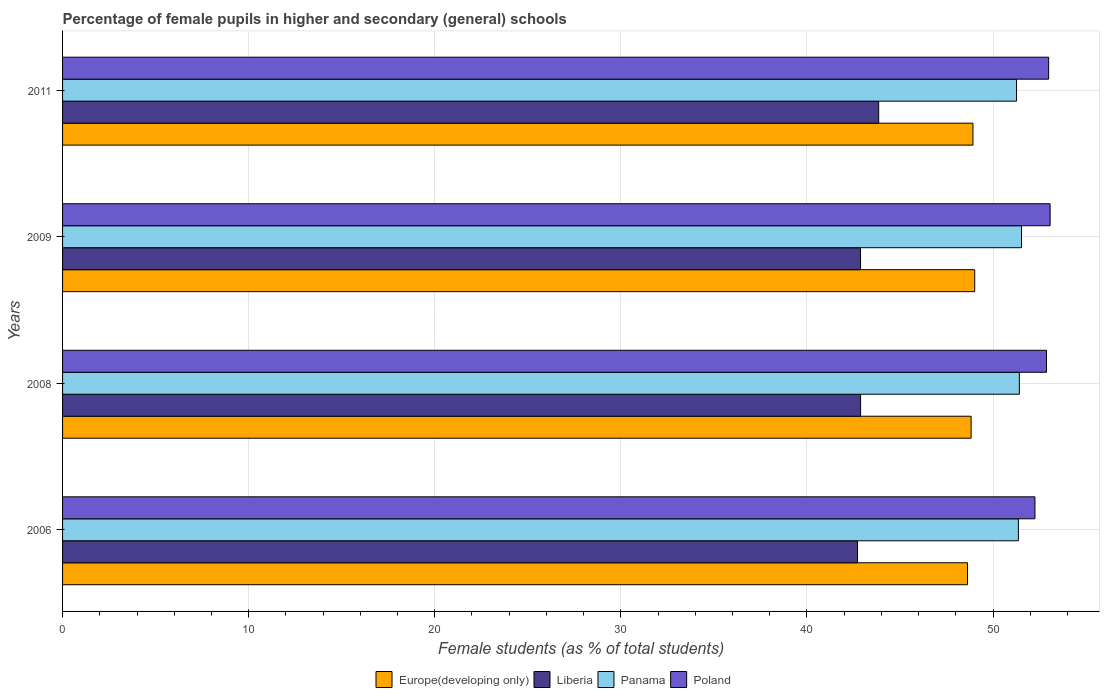How many different coloured bars are there?
Your answer should be compact. 4. How many bars are there on the 3rd tick from the bottom?
Give a very brief answer. 4. In how many cases, is the number of bars for a given year not equal to the number of legend labels?
Your answer should be compact. 0. What is the percentage of female pupils in higher and secondary schools in Panama in 2008?
Make the answer very short. 51.41. Across all years, what is the maximum percentage of female pupils in higher and secondary schools in Poland?
Provide a short and direct response. 53.07. Across all years, what is the minimum percentage of female pupils in higher and secondary schools in Poland?
Make the answer very short. 52.25. In which year was the percentage of female pupils in higher and secondary schools in Poland maximum?
Ensure brevity in your answer.  2009. In which year was the percentage of female pupils in higher and secondary schools in Poland minimum?
Ensure brevity in your answer.  2006. What is the total percentage of female pupils in higher and secondary schools in Liberia in the graph?
Ensure brevity in your answer.  172.34. What is the difference between the percentage of female pupils in higher and secondary schools in Panama in 2008 and that in 2009?
Your answer should be compact. -0.12. What is the difference between the percentage of female pupils in higher and secondary schools in Poland in 2006 and the percentage of female pupils in higher and secondary schools in Europe(developing only) in 2011?
Provide a succinct answer. 3.33. What is the average percentage of female pupils in higher and secondary schools in Liberia per year?
Your answer should be very brief. 43.08. In the year 2011, what is the difference between the percentage of female pupils in higher and secondary schools in Europe(developing only) and percentage of female pupils in higher and secondary schools in Liberia?
Provide a short and direct response. 5.07. In how many years, is the percentage of female pupils in higher and secondary schools in Poland greater than 42 %?
Offer a very short reply. 4. What is the ratio of the percentage of female pupils in higher and secondary schools in Europe(developing only) in 2009 to that in 2011?
Give a very brief answer. 1. Is the percentage of female pupils in higher and secondary schools in Poland in 2008 less than that in 2011?
Give a very brief answer. Yes. Is the difference between the percentage of female pupils in higher and secondary schools in Europe(developing only) in 2006 and 2009 greater than the difference between the percentage of female pupils in higher and secondary schools in Liberia in 2006 and 2009?
Your answer should be very brief. No. What is the difference between the highest and the second highest percentage of female pupils in higher and secondary schools in Europe(developing only)?
Offer a very short reply. 0.09. What is the difference between the highest and the lowest percentage of female pupils in higher and secondary schools in Liberia?
Your answer should be very brief. 1.14. Is it the case that in every year, the sum of the percentage of female pupils in higher and secondary schools in Liberia and percentage of female pupils in higher and secondary schools in Poland is greater than the sum of percentage of female pupils in higher and secondary schools in Europe(developing only) and percentage of female pupils in higher and secondary schools in Panama?
Provide a short and direct response. Yes. What does the 3rd bar from the top in 2008 represents?
Provide a short and direct response. Liberia. What does the 3rd bar from the bottom in 2011 represents?
Provide a succinct answer. Panama. How many bars are there?
Your answer should be compact. 16. How many years are there in the graph?
Your answer should be compact. 4. What is the difference between two consecutive major ticks on the X-axis?
Keep it short and to the point. 10. Does the graph contain grids?
Your answer should be very brief. Yes. Where does the legend appear in the graph?
Provide a short and direct response. Bottom center. How many legend labels are there?
Make the answer very short. 4. How are the legend labels stacked?
Provide a succinct answer. Horizontal. What is the title of the graph?
Your answer should be very brief. Percentage of female pupils in higher and secondary (general) schools. Does "Madagascar" appear as one of the legend labels in the graph?
Provide a succinct answer. No. What is the label or title of the X-axis?
Offer a terse response. Female students (as % of total students). What is the label or title of the Y-axis?
Give a very brief answer. Years. What is the Female students (as % of total students) in Europe(developing only) in 2006?
Provide a short and direct response. 48.63. What is the Female students (as % of total students) in Liberia in 2006?
Keep it short and to the point. 42.72. What is the Female students (as % of total students) of Panama in 2006?
Your answer should be compact. 51.36. What is the Female students (as % of total students) of Poland in 2006?
Give a very brief answer. 52.25. What is the Female students (as % of total students) of Europe(developing only) in 2008?
Keep it short and to the point. 48.82. What is the Female students (as % of total students) in Liberia in 2008?
Keep it short and to the point. 42.88. What is the Female students (as % of total students) of Panama in 2008?
Make the answer very short. 51.41. What is the Female students (as % of total students) of Poland in 2008?
Provide a short and direct response. 52.87. What is the Female students (as % of total students) of Europe(developing only) in 2009?
Your response must be concise. 49.02. What is the Female students (as % of total students) in Liberia in 2009?
Offer a terse response. 42.88. What is the Female students (as % of total students) in Panama in 2009?
Offer a terse response. 51.53. What is the Female students (as % of total students) of Poland in 2009?
Your response must be concise. 53.07. What is the Female students (as % of total students) in Europe(developing only) in 2011?
Give a very brief answer. 48.92. What is the Female students (as % of total students) in Liberia in 2011?
Offer a terse response. 43.85. What is the Female students (as % of total students) in Panama in 2011?
Keep it short and to the point. 51.26. What is the Female students (as % of total students) in Poland in 2011?
Provide a succinct answer. 52.99. Across all years, what is the maximum Female students (as % of total students) of Europe(developing only)?
Offer a very short reply. 49.02. Across all years, what is the maximum Female students (as % of total students) of Liberia?
Offer a terse response. 43.85. Across all years, what is the maximum Female students (as % of total students) in Panama?
Your answer should be very brief. 51.53. Across all years, what is the maximum Female students (as % of total students) in Poland?
Offer a very short reply. 53.07. Across all years, what is the minimum Female students (as % of total students) of Europe(developing only)?
Your answer should be very brief. 48.63. Across all years, what is the minimum Female students (as % of total students) of Liberia?
Provide a succinct answer. 42.72. Across all years, what is the minimum Female students (as % of total students) in Panama?
Provide a short and direct response. 51.26. Across all years, what is the minimum Female students (as % of total students) of Poland?
Your answer should be very brief. 52.25. What is the total Female students (as % of total students) in Europe(developing only) in the graph?
Offer a terse response. 195.38. What is the total Female students (as % of total students) of Liberia in the graph?
Your answer should be very brief. 172.34. What is the total Female students (as % of total students) in Panama in the graph?
Ensure brevity in your answer.  205.57. What is the total Female students (as % of total students) in Poland in the graph?
Your answer should be compact. 211.18. What is the difference between the Female students (as % of total students) in Europe(developing only) in 2006 and that in 2008?
Keep it short and to the point. -0.2. What is the difference between the Female students (as % of total students) in Liberia in 2006 and that in 2008?
Keep it short and to the point. -0.17. What is the difference between the Female students (as % of total students) in Panama in 2006 and that in 2008?
Give a very brief answer. -0.05. What is the difference between the Female students (as % of total students) of Poland in 2006 and that in 2008?
Provide a short and direct response. -0.62. What is the difference between the Female students (as % of total students) of Europe(developing only) in 2006 and that in 2009?
Offer a very short reply. -0.39. What is the difference between the Female students (as % of total students) in Liberia in 2006 and that in 2009?
Ensure brevity in your answer.  -0.16. What is the difference between the Female students (as % of total students) of Panama in 2006 and that in 2009?
Provide a short and direct response. -0.17. What is the difference between the Female students (as % of total students) in Poland in 2006 and that in 2009?
Provide a succinct answer. -0.81. What is the difference between the Female students (as % of total students) in Europe(developing only) in 2006 and that in 2011?
Provide a short and direct response. -0.29. What is the difference between the Female students (as % of total students) in Liberia in 2006 and that in 2011?
Your answer should be compact. -1.14. What is the difference between the Female students (as % of total students) in Panama in 2006 and that in 2011?
Provide a succinct answer. 0.1. What is the difference between the Female students (as % of total students) in Poland in 2006 and that in 2011?
Give a very brief answer. -0.74. What is the difference between the Female students (as % of total students) in Europe(developing only) in 2008 and that in 2009?
Ensure brevity in your answer.  -0.19. What is the difference between the Female students (as % of total students) in Liberia in 2008 and that in 2009?
Give a very brief answer. 0. What is the difference between the Female students (as % of total students) in Panama in 2008 and that in 2009?
Offer a terse response. -0.12. What is the difference between the Female students (as % of total students) in Poland in 2008 and that in 2009?
Offer a terse response. -0.19. What is the difference between the Female students (as % of total students) of Europe(developing only) in 2008 and that in 2011?
Give a very brief answer. -0.1. What is the difference between the Female students (as % of total students) in Liberia in 2008 and that in 2011?
Your answer should be compact. -0.97. What is the difference between the Female students (as % of total students) of Panama in 2008 and that in 2011?
Give a very brief answer. 0.15. What is the difference between the Female students (as % of total students) in Poland in 2008 and that in 2011?
Your answer should be very brief. -0.12. What is the difference between the Female students (as % of total students) of Europe(developing only) in 2009 and that in 2011?
Offer a terse response. 0.09. What is the difference between the Female students (as % of total students) of Liberia in 2009 and that in 2011?
Provide a short and direct response. -0.97. What is the difference between the Female students (as % of total students) of Panama in 2009 and that in 2011?
Your answer should be compact. 0.27. What is the difference between the Female students (as % of total students) of Poland in 2009 and that in 2011?
Your answer should be compact. 0.08. What is the difference between the Female students (as % of total students) in Europe(developing only) in 2006 and the Female students (as % of total students) in Liberia in 2008?
Offer a terse response. 5.74. What is the difference between the Female students (as % of total students) in Europe(developing only) in 2006 and the Female students (as % of total students) in Panama in 2008?
Ensure brevity in your answer.  -2.79. What is the difference between the Female students (as % of total students) in Europe(developing only) in 2006 and the Female students (as % of total students) in Poland in 2008?
Give a very brief answer. -4.25. What is the difference between the Female students (as % of total students) in Liberia in 2006 and the Female students (as % of total students) in Panama in 2008?
Keep it short and to the point. -8.7. What is the difference between the Female students (as % of total students) of Liberia in 2006 and the Female students (as % of total students) of Poland in 2008?
Make the answer very short. -10.15. What is the difference between the Female students (as % of total students) of Panama in 2006 and the Female students (as % of total students) of Poland in 2008?
Your answer should be very brief. -1.51. What is the difference between the Female students (as % of total students) in Europe(developing only) in 2006 and the Female students (as % of total students) in Liberia in 2009?
Give a very brief answer. 5.75. What is the difference between the Female students (as % of total students) in Europe(developing only) in 2006 and the Female students (as % of total students) in Panama in 2009?
Offer a very short reply. -2.9. What is the difference between the Female students (as % of total students) in Europe(developing only) in 2006 and the Female students (as % of total students) in Poland in 2009?
Your response must be concise. -4.44. What is the difference between the Female students (as % of total students) in Liberia in 2006 and the Female students (as % of total students) in Panama in 2009?
Offer a very short reply. -8.81. What is the difference between the Female students (as % of total students) of Liberia in 2006 and the Female students (as % of total students) of Poland in 2009?
Your response must be concise. -10.35. What is the difference between the Female students (as % of total students) in Panama in 2006 and the Female students (as % of total students) in Poland in 2009?
Offer a terse response. -1.7. What is the difference between the Female students (as % of total students) of Europe(developing only) in 2006 and the Female students (as % of total students) of Liberia in 2011?
Ensure brevity in your answer.  4.77. What is the difference between the Female students (as % of total students) in Europe(developing only) in 2006 and the Female students (as % of total students) in Panama in 2011?
Ensure brevity in your answer.  -2.64. What is the difference between the Female students (as % of total students) in Europe(developing only) in 2006 and the Female students (as % of total students) in Poland in 2011?
Keep it short and to the point. -4.36. What is the difference between the Female students (as % of total students) in Liberia in 2006 and the Female students (as % of total students) in Panama in 2011?
Offer a terse response. -8.55. What is the difference between the Female students (as % of total students) in Liberia in 2006 and the Female students (as % of total students) in Poland in 2011?
Provide a succinct answer. -10.27. What is the difference between the Female students (as % of total students) in Panama in 2006 and the Female students (as % of total students) in Poland in 2011?
Make the answer very short. -1.62. What is the difference between the Female students (as % of total students) of Europe(developing only) in 2008 and the Female students (as % of total students) of Liberia in 2009?
Provide a succinct answer. 5.94. What is the difference between the Female students (as % of total students) in Europe(developing only) in 2008 and the Female students (as % of total students) in Panama in 2009?
Give a very brief answer. -2.71. What is the difference between the Female students (as % of total students) of Europe(developing only) in 2008 and the Female students (as % of total students) of Poland in 2009?
Keep it short and to the point. -4.24. What is the difference between the Female students (as % of total students) of Liberia in 2008 and the Female students (as % of total students) of Panama in 2009?
Provide a short and direct response. -8.65. What is the difference between the Female students (as % of total students) in Liberia in 2008 and the Female students (as % of total students) in Poland in 2009?
Offer a terse response. -10.18. What is the difference between the Female students (as % of total students) in Panama in 2008 and the Female students (as % of total students) in Poland in 2009?
Give a very brief answer. -1.65. What is the difference between the Female students (as % of total students) of Europe(developing only) in 2008 and the Female students (as % of total students) of Liberia in 2011?
Your response must be concise. 4.97. What is the difference between the Female students (as % of total students) of Europe(developing only) in 2008 and the Female students (as % of total students) of Panama in 2011?
Your answer should be very brief. -2.44. What is the difference between the Female students (as % of total students) in Europe(developing only) in 2008 and the Female students (as % of total students) in Poland in 2011?
Ensure brevity in your answer.  -4.17. What is the difference between the Female students (as % of total students) of Liberia in 2008 and the Female students (as % of total students) of Panama in 2011?
Your answer should be compact. -8.38. What is the difference between the Female students (as % of total students) of Liberia in 2008 and the Female students (as % of total students) of Poland in 2011?
Give a very brief answer. -10.1. What is the difference between the Female students (as % of total students) in Panama in 2008 and the Female students (as % of total students) in Poland in 2011?
Your response must be concise. -1.57. What is the difference between the Female students (as % of total students) of Europe(developing only) in 2009 and the Female students (as % of total students) of Liberia in 2011?
Provide a succinct answer. 5.16. What is the difference between the Female students (as % of total students) of Europe(developing only) in 2009 and the Female students (as % of total students) of Panama in 2011?
Provide a succinct answer. -2.25. What is the difference between the Female students (as % of total students) in Europe(developing only) in 2009 and the Female students (as % of total students) in Poland in 2011?
Offer a very short reply. -3.97. What is the difference between the Female students (as % of total students) in Liberia in 2009 and the Female students (as % of total students) in Panama in 2011?
Provide a succinct answer. -8.38. What is the difference between the Female students (as % of total students) of Liberia in 2009 and the Female students (as % of total students) of Poland in 2011?
Your answer should be very brief. -10.11. What is the difference between the Female students (as % of total students) of Panama in 2009 and the Female students (as % of total students) of Poland in 2011?
Keep it short and to the point. -1.46. What is the average Female students (as % of total students) of Europe(developing only) per year?
Offer a very short reply. 48.85. What is the average Female students (as % of total students) in Liberia per year?
Your answer should be compact. 43.08. What is the average Female students (as % of total students) of Panama per year?
Give a very brief answer. 51.39. What is the average Female students (as % of total students) of Poland per year?
Offer a very short reply. 52.79. In the year 2006, what is the difference between the Female students (as % of total students) of Europe(developing only) and Female students (as % of total students) of Liberia?
Ensure brevity in your answer.  5.91. In the year 2006, what is the difference between the Female students (as % of total students) in Europe(developing only) and Female students (as % of total students) in Panama?
Offer a very short reply. -2.74. In the year 2006, what is the difference between the Female students (as % of total students) in Europe(developing only) and Female students (as % of total students) in Poland?
Your response must be concise. -3.63. In the year 2006, what is the difference between the Female students (as % of total students) in Liberia and Female students (as % of total students) in Panama?
Offer a very short reply. -8.65. In the year 2006, what is the difference between the Female students (as % of total students) in Liberia and Female students (as % of total students) in Poland?
Make the answer very short. -9.53. In the year 2006, what is the difference between the Female students (as % of total students) of Panama and Female students (as % of total students) of Poland?
Give a very brief answer. -0.89. In the year 2008, what is the difference between the Female students (as % of total students) of Europe(developing only) and Female students (as % of total students) of Liberia?
Offer a terse response. 5.94. In the year 2008, what is the difference between the Female students (as % of total students) in Europe(developing only) and Female students (as % of total students) in Panama?
Give a very brief answer. -2.59. In the year 2008, what is the difference between the Female students (as % of total students) of Europe(developing only) and Female students (as % of total students) of Poland?
Offer a very short reply. -4.05. In the year 2008, what is the difference between the Female students (as % of total students) of Liberia and Female students (as % of total students) of Panama?
Give a very brief answer. -8.53. In the year 2008, what is the difference between the Female students (as % of total students) in Liberia and Female students (as % of total students) in Poland?
Make the answer very short. -9.99. In the year 2008, what is the difference between the Female students (as % of total students) in Panama and Female students (as % of total students) in Poland?
Your answer should be compact. -1.46. In the year 2009, what is the difference between the Female students (as % of total students) of Europe(developing only) and Female students (as % of total students) of Liberia?
Offer a terse response. 6.13. In the year 2009, what is the difference between the Female students (as % of total students) in Europe(developing only) and Female students (as % of total students) in Panama?
Provide a short and direct response. -2.51. In the year 2009, what is the difference between the Female students (as % of total students) of Europe(developing only) and Female students (as % of total students) of Poland?
Your answer should be compact. -4.05. In the year 2009, what is the difference between the Female students (as % of total students) in Liberia and Female students (as % of total students) in Panama?
Offer a terse response. -8.65. In the year 2009, what is the difference between the Female students (as % of total students) of Liberia and Female students (as % of total students) of Poland?
Your response must be concise. -10.19. In the year 2009, what is the difference between the Female students (as % of total students) of Panama and Female students (as % of total students) of Poland?
Offer a very short reply. -1.54. In the year 2011, what is the difference between the Female students (as % of total students) in Europe(developing only) and Female students (as % of total students) in Liberia?
Your answer should be compact. 5.07. In the year 2011, what is the difference between the Female students (as % of total students) of Europe(developing only) and Female students (as % of total students) of Panama?
Your response must be concise. -2.34. In the year 2011, what is the difference between the Female students (as % of total students) in Europe(developing only) and Female students (as % of total students) in Poland?
Give a very brief answer. -4.07. In the year 2011, what is the difference between the Female students (as % of total students) of Liberia and Female students (as % of total students) of Panama?
Your response must be concise. -7.41. In the year 2011, what is the difference between the Female students (as % of total students) of Liberia and Female students (as % of total students) of Poland?
Offer a terse response. -9.13. In the year 2011, what is the difference between the Female students (as % of total students) in Panama and Female students (as % of total students) in Poland?
Your response must be concise. -1.72. What is the ratio of the Female students (as % of total students) in Liberia in 2006 to that in 2008?
Ensure brevity in your answer.  1. What is the ratio of the Female students (as % of total students) in Poland in 2006 to that in 2008?
Offer a terse response. 0.99. What is the ratio of the Female students (as % of total students) in Europe(developing only) in 2006 to that in 2009?
Offer a terse response. 0.99. What is the ratio of the Female students (as % of total students) of Panama in 2006 to that in 2009?
Provide a short and direct response. 1. What is the ratio of the Female students (as % of total students) in Poland in 2006 to that in 2009?
Give a very brief answer. 0.98. What is the ratio of the Female students (as % of total students) of Liberia in 2006 to that in 2011?
Offer a terse response. 0.97. What is the ratio of the Female students (as % of total students) of Panama in 2006 to that in 2011?
Offer a terse response. 1. What is the ratio of the Female students (as % of total students) of Poland in 2006 to that in 2011?
Provide a short and direct response. 0.99. What is the ratio of the Female students (as % of total students) in Europe(developing only) in 2008 to that in 2009?
Your answer should be very brief. 1. What is the ratio of the Female students (as % of total students) of Panama in 2008 to that in 2009?
Offer a terse response. 1. What is the ratio of the Female students (as % of total students) in Europe(developing only) in 2008 to that in 2011?
Keep it short and to the point. 1. What is the ratio of the Female students (as % of total students) of Liberia in 2008 to that in 2011?
Your answer should be very brief. 0.98. What is the ratio of the Female students (as % of total students) in Europe(developing only) in 2009 to that in 2011?
Make the answer very short. 1. What is the ratio of the Female students (as % of total students) in Liberia in 2009 to that in 2011?
Ensure brevity in your answer.  0.98. What is the difference between the highest and the second highest Female students (as % of total students) in Europe(developing only)?
Offer a terse response. 0.09. What is the difference between the highest and the second highest Female students (as % of total students) in Liberia?
Offer a very short reply. 0.97. What is the difference between the highest and the second highest Female students (as % of total students) of Panama?
Your answer should be very brief. 0.12. What is the difference between the highest and the second highest Female students (as % of total students) of Poland?
Make the answer very short. 0.08. What is the difference between the highest and the lowest Female students (as % of total students) of Europe(developing only)?
Your answer should be compact. 0.39. What is the difference between the highest and the lowest Female students (as % of total students) in Liberia?
Your answer should be compact. 1.14. What is the difference between the highest and the lowest Female students (as % of total students) in Panama?
Your answer should be compact. 0.27. What is the difference between the highest and the lowest Female students (as % of total students) of Poland?
Ensure brevity in your answer.  0.81. 